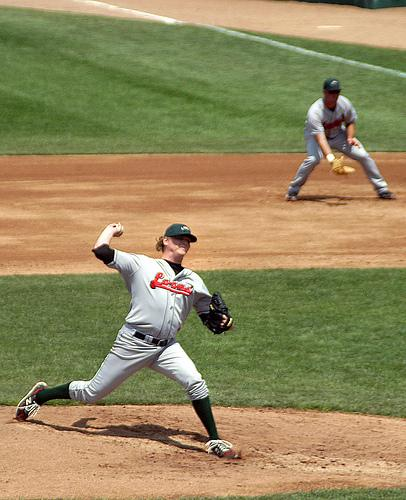Write a brief description of the image focusing on the central action taking place. A pitcher is in the midst of throwing a ball while standing on the mound amidst a well-tended baseball field. Create a sentence that encapsulates the primary activity and surroundings in the picture. A baseball game in progress features a pitcher throwing a ball on a neatly groomed field with distinct white lines and patches of green grass. Express the scene from the perspective of a person observing the event in the picture. I'm watching a baseball player on a well-kept field get ready to throw a ball while wearing a remarkable uniform with red lettering and a dark baseball cap. Compose a description of the photograph in a conversational tone, as if explaining the scene to a friend. Hey, check out this cool image of a baseball player preparing to throw a ball on a really well-maintained field—the guy has a super distinct uniform with red writing on it and a black hat! Write a concise overview of the picture, highlighting only the most crucial elements present. Baseball player on the mound, ready to throw a ball, in a uniform with red writing and identifiable gear. Describe the picture in the form of a sentence containing the most eye-catching objects or actions. A baseball player on a green field prepares to throw the ball, as his dark glove, hat, and uniform with red writing stand out prominently. Provide a narrative of the image with emphasis on the prominent figure. Standing tall on the mound of a beautifully maintained baseball field, a focused player gets ready to hurl a fast pitch, wearing a striking uniform with red lettering and a dark hat. Imagine you are describing the scene to a child, using simple language and focusing on the most significant part of the image. There's a baseball player about to throw a ball on a bright green field, and he's wearing a special outfit with red letters and a dark hat. Give a brief account of the main subject in the photo and the setting in which they are placed. A baseball pitcher is standing on the mound of a well-groomed field, preparing to throw a ball, while wearing a notable uniform with red lettering. Describe the main components in the image using straightforward language. On a baseball field, a player wearing a uniform and holding a glove is in the process of throwing a ball. 